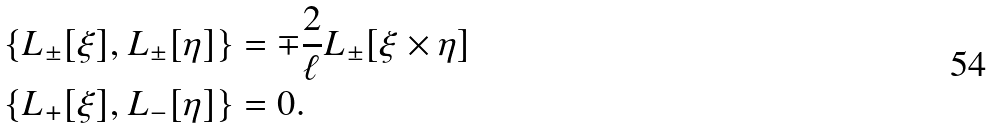Convert formula to latex. <formula><loc_0><loc_0><loc_500><loc_500>& \left \{ L _ { \pm } [ \xi ] , L _ { \pm } [ \eta ] \right \} = \mp { \frac { 2 } { \ell } } L _ { \pm } [ \xi \times \eta ] \\ & \left \{ L _ { + } [ \xi ] , L _ { - } [ \eta ] \right \} = 0 .</formula> 